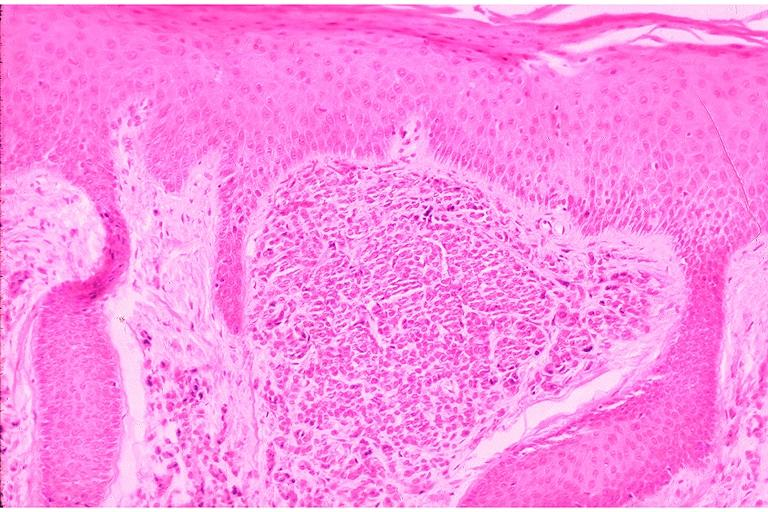what is present?
Answer the question using a single word or phrase. Oral 